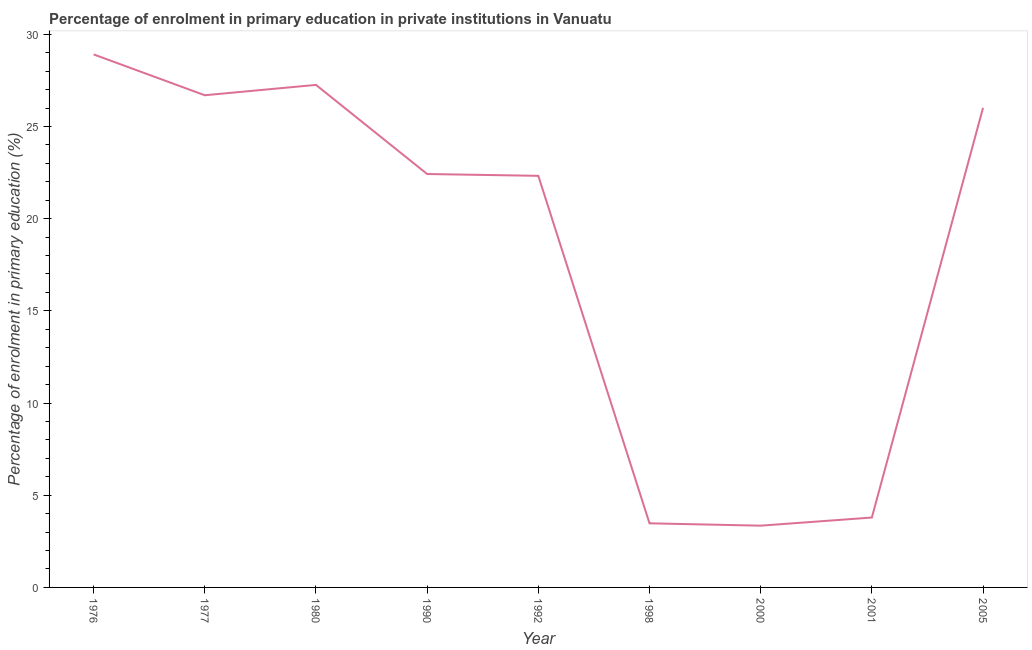What is the enrolment percentage in primary education in 1977?
Ensure brevity in your answer.  26.7. Across all years, what is the maximum enrolment percentage in primary education?
Offer a very short reply. 28.91. Across all years, what is the minimum enrolment percentage in primary education?
Ensure brevity in your answer.  3.35. In which year was the enrolment percentage in primary education maximum?
Provide a succinct answer. 1976. In which year was the enrolment percentage in primary education minimum?
Keep it short and to the point. 2000. What is the sum of the enrolment percentage in primary education?
Your answer should be compact. 164.24. What is the difference between the enrolment percentage in primary education in 1998 and 2005?
Provide a short and direct response. -22.53. What is the average enrolment percentage in primary education per year?
Your response must be concise. 18.25. What is the median enrolment percentage in primary education?
Provide a succinct answer. 22.42. What is the ratio of the enrolment percentage in primary education in 1992 to that in 2005?
Keep it short and to the point. 0.86. Is the difference between the enrolment percentage in primary education in 1976 and 2005 greater than the difference between any two years?
Provide a succinct answer. No. What is the difference between the highest and the second highest enrolment percentage in primary education?
Your response must be concise. 1.65. What is the difference between the highest and the lowest enrolment percentage in primary education?
Your answer should be compact. 25.56. Does the enrolment percentage in primary education monotonically increase over the years?
Ensure brevity in your answer.  No. How many lines are there?
Your response must be concise. 1. How many years are there in the graph?
Give a very brief answer. 9. Are the values on the major ticks of Y-axis written in scientific E-notation?
Your answer should be very brief. No. Does the graph contain any zero values?
Your answer should be very brief. No. What is the title of the graph?
Offer a terse response. Percentage of enrolment in primary education in private institutions in Vanuatu. What is the label or title of the Y-axis?
Your answer should be very brief. Percentage of enrolment in primary education (%). What is the Percentage of enrolment in primary education (%) in 1976?
Provide a short and direct response. 28.91. What is the Percentage of enrolment in primary education (%) of 1977?
Give a very brief answer. 26.7. What is the Percentage of enrolment in primary education (%) of 1980?
Your answer should be compact. 27.26. What is the Percentage of enrolment in primary education (%) of 1990?
Your answer should be very brief. 22.42. What is the Percentage of enrolment in primary education (%) in 1992?
Your response must be concise. 22.32. What is the Percentage of enrolment in primary education (%) of 1998?
Ensure brevity in your answer.  3.48. What is the Percentage of enrolment in primary education (%) of 2000?
Ensure brevity in your answer.  3.35. What is the Percentage of enrolment in primary education (%) of 2001?
Give a very brief answer. 3.79. What is the Percentage of enrolment in primary education (%) in 2005?
Your response must be concise. 26.01. What is the difference between the Percentage of enrolment in primary education (%) in 1976 and 1977?
Make the answer very short. 2.22. What is the difference between the Percentage of enrolment in primary education (%) in 1976 and 1980?
Offer a very short reply. 1.65. What is the difference between the Percentage of enrolment in primary education (%) in 1976 and 1990?
Give a very brief answer. 6.49. What is the difference between the Percentage of enrolment in primary education (%) in 1976 and 1992?
Your answer should be very brief. 6.59. What is the difference between the Percentage of enrolment in primary education (%) in 1976 and 1998?
Give a very brief answer. 25.43. What is the difference between the Percentage of enrolment in primary education (%) in 1976 and 2000?
Ensure brevity in your answer.  25.56. What is the difference between the Percentage of enrolment in primary education (%) in 1976 and 2001?
Provide a short and direct response. 25.12. What is the difference between the Percentage of enrolment in primary education (%) in 1976 and 2005?
Your answer should be very brief. 2.9. What is the difference between the Percentage of enrolment in primary education (%) in 1977 and 1980?
Your response must be concise. -0.56. What is the difference between the Percentage of enrolment in primary education (%) in 1977 and 1990?
Offer a terse response. 4.27. What is the difference between the Percentage of enrolment in primary education (%) in 1977 and 1992?
Make the answer very short. 4.37. What is the difference between the Percentage of enrolment in primary education (%) in 1977 and 1998?
Give a very brief answer. 23.22. What is the difference between the Percentage of enrolment in primary education (%) in 1977 and 2000?
Ensure brevity in your answer.  23.35. What is the difference between the Percentage of enrolment in primary education (%) in 1977 and 2001?
Give a very brief answer. 22.9. What is the difference between the Percentage of enrolment in primary education (%) in 1977 and 2005?
Your answer should be very brief. 0.68. What is the difference between the Percentage of enrolment in primary education (%) in 1980 and 1990?
Ensure brevity in your answer.  4.83. What is the difference between the Percentage of enrolment in primary education (%) in 1980 and 1992?
Your answer should be very brief. 4.93. What is the difference between the Percentage of enrolment in primary education (%) in 1980 and 1998?
Offer a terse response. 23.78. What is the difference between the Percentage of enrolment in primary education (%) in 1980 and 2000?
Provide a short and direct response. 23.91. What is the difference between the Percentage of enrolment in primary education (%) in 1980 and 2001?
Your answer should be compact. 23.47. What is the difference between the Percentage of enrolment in primary education (%) in 1980 and 2005?
Ensure brevity in your answer.  1.25. What is the difference between the Percentage of enrolment in primary education (%) in 1990 and 1992?
Offer a terse response. 0.1. What is the difference between the Percentage of enrolment in primary education (%) in 1990 and 1998?
Give a very brief answer. 18.95. What is the difference between the Percentage of enrolment in primary education (%) in 1990 and 2000?
Your answer should be very brief. 19.07. What is the difference between the Percentage of enrolment in primary education (%) in 1990 and 2001?
Provide a succinct answer. 18.63. What is the difference between the Percentage of enrolment in primary education (%) in 1990 and 2005?
Make the answer very short. -3.59. What is the difference between the Percentage of enrolment in primary education (%) in 1992 and 1998?
Your response must be concise. 18.85. What is the difference between the Percentage of enrolment in primary education (%) in 1992 and 2000?
Give a very brief answer. 18.97. What is the difference between the Percentage of enrolment in primary education (%) in 1992 and 2001?
Ensure brevity in your answer.  18.53. What is the difference between the Percentage of enrolment in primary education (%) in 1992 and 2005?
Ensure brevity in your answer.  -3.69. What is the difference between the Percentage of enrolment in primary education (%) in 1998 and 2000?
Provide a short and direct response. 0.13. What is the difference between the Percentage of enrolment in primary education (%) in 1998 and 2001?
Keep it short and to the point. -0.31. What is the difference between the Percentage of enrolment in primary education (%) in 1998 and 2005?
Give a very brief answer. -22.53. What is the difference between the Percentage of enrolment in primary education (%) in 2000 and 2001?
Your answer should be very brief. -0.44. What is the difference between the Percentage of enrolment in primary education (%) in 2000 and 2005?
Provide a succinct answer. -22.66. What is the difference between the Percentage of enrolment in primary education (%) in 2001 and 2005?
Offer a terse response. -22.22. What is the ratio of the Percentage of enrolment in primary education (%) in 1976 to that in 1977?
Ensure brevity in your answer.  1.08. What is the ratio of the Percentage of enrolment in primary education (%) in 1976 to that in 1980?
Your answer should be very brief. 1.06. What is the ratio of the Percentage of enrolment in primary education (%) in 1976 to that in 1990?
Your answer should be very brief. 1.29. What is the ratio of the Percentage of enrolment in primary education (%) in 1976 to that in 1992?
Provide a succinct answer. 1.29. What is the ratio of the Percentage of enrolment in primary education (%) in 1976 to that in 1998?
Ensure brevity in your answer.  8.31. What is the ratio of the Percentage of enrolment in primary education (%) in 1976 to that in 2000?
Give a very brief answer. 8.63. What is the ratio of the Percentage of enrolment in primary education (%) in 1976 to that in 2001?
Your response must be concise. 7.63. What is the ratio of the Percentage of enrolment in primary education (%) in 1976 to that in 2005?
Your answer should be compact. 1.11. What is the ratio of the Percentage of enrolment in primary education (%) in 1977 to that in 1980?
Your answer should be compact. 0.98. What is the ratio of the Percentage of enrolment in primary education (%) in 1977 to that in 1990?
Provide a succinct answer. 1.19. What is the ratio of the Percentage of enrolment in primary education (%) in 1977 to that in 1992?
Your response must be concise. 1.2. What is the ratio of the Percentage of enrolment in primary education (%) in 1977 to that in 1998?
Provide a succinct answer. 7.68. What is the ratio of the Percentage of enrolment in primary education (%) in 1977 to that in 2000?
Offer a very short reply. 7.97. What is the ratio of the Percentage of enrolment in primary education (%) in 1977 to that in 2001?
Keep it short and to the point. 7.04. What is the ratio of the Percentage of enrolment in primary education (%) in 1977 to that in 2005?
Give a very brief answer. 1.03. What is the ratio of the Percentage of enrolment in primary education (%) in 1980 to that in 1990?
Ensure brevity in your answer.  1.22. What is the ratio of the Percentage of enrolment in primary education (%) in 1980 to that in 1992?
Provide a succinct answer. 1.22. What is the ratio of the Percentage of enrolment in primary education (%) in 1980 to that in 1998?
Your answer should be very brief. 7.84. What is the ratio of the Percentage of enrolment in primary education (%) in 1980 to that in 2000?
Ensure brevity in your answer.  8.14. What is the ratio of the Percentage of enrolment in primary education (%) in 1980 to that in 2001?
Your answer should be compact. 7.19. What is the ratio of the Percentage of enrolment in primary education (%) in 1980 to that in 2005?
Give a very brief answer. 1.05. What is the ratio of the Percentage of enrolment in primary education (%) in 1990 to that in 1992?
Offer a terse response. 1. What is the ratio of the Percentage of enrolment in primary education (%) in 1990 to that in 1998?
Offer a very short reply. 6.45. What is the ratio of the Percentage of enrolment in primary education (%) in 1990 to that in 2000?
Offer a very short reply. 6.69. What is the ratio of the Percentage of enrolment in primary education (%) in 1990 to that in 2001?
Offer a very short reply. 5.92. What is the ratio of the Percentage of enrolment in primary education (%) in 1990 to that in 2005?
Give a very brief answer. 0.86. What is the ratio of the Percentage of enrolment in primary education (%) in 1992 to that in 1998?
Make the answer very short. 6.42. What is the ratio of the Percentage of enrolment in primary education (%) in 1992 to that in 2000?
Ensure brevity in your answer.  6.66. What is the ratio of the Percentage of enrolment in primary education (%) in 1992 to that in 2001?
Your answer should be very brief. 5.89. What is the ratio of the Percentage of enrolment in primary education (%) in 1992 to that in 2005?
Your answer should be very brief. 0.86. What is the ratio of the Percentage of enrolment in primary education (%) in 1998 to that in 2000?
Ensure brevity in your answer.  1.04. What is the ratio of the Percentage of enrolment in primary education (%) in 1998 to that in 2001?
Offer a very short reply. 0.92. What is the ratio of the Percentage of enrolment in primary education (%) in 1998 to that in 2005?
Your response must be concise. 0.13. What is the ratio of the Percentage of enrolment in primary education (%) in 2000 to that in 2001?
Your answer should be very brief. 0.88. What is the ratio of the Percentage of enrolment in primary education (%) in 2000 to that in 2005?
Offer a very short reply. 0.13. What is the ratio of the Percentage of enrolment in primary education (%) in 2001 to that in 2005?
Give a very brief answer. 0.15. 